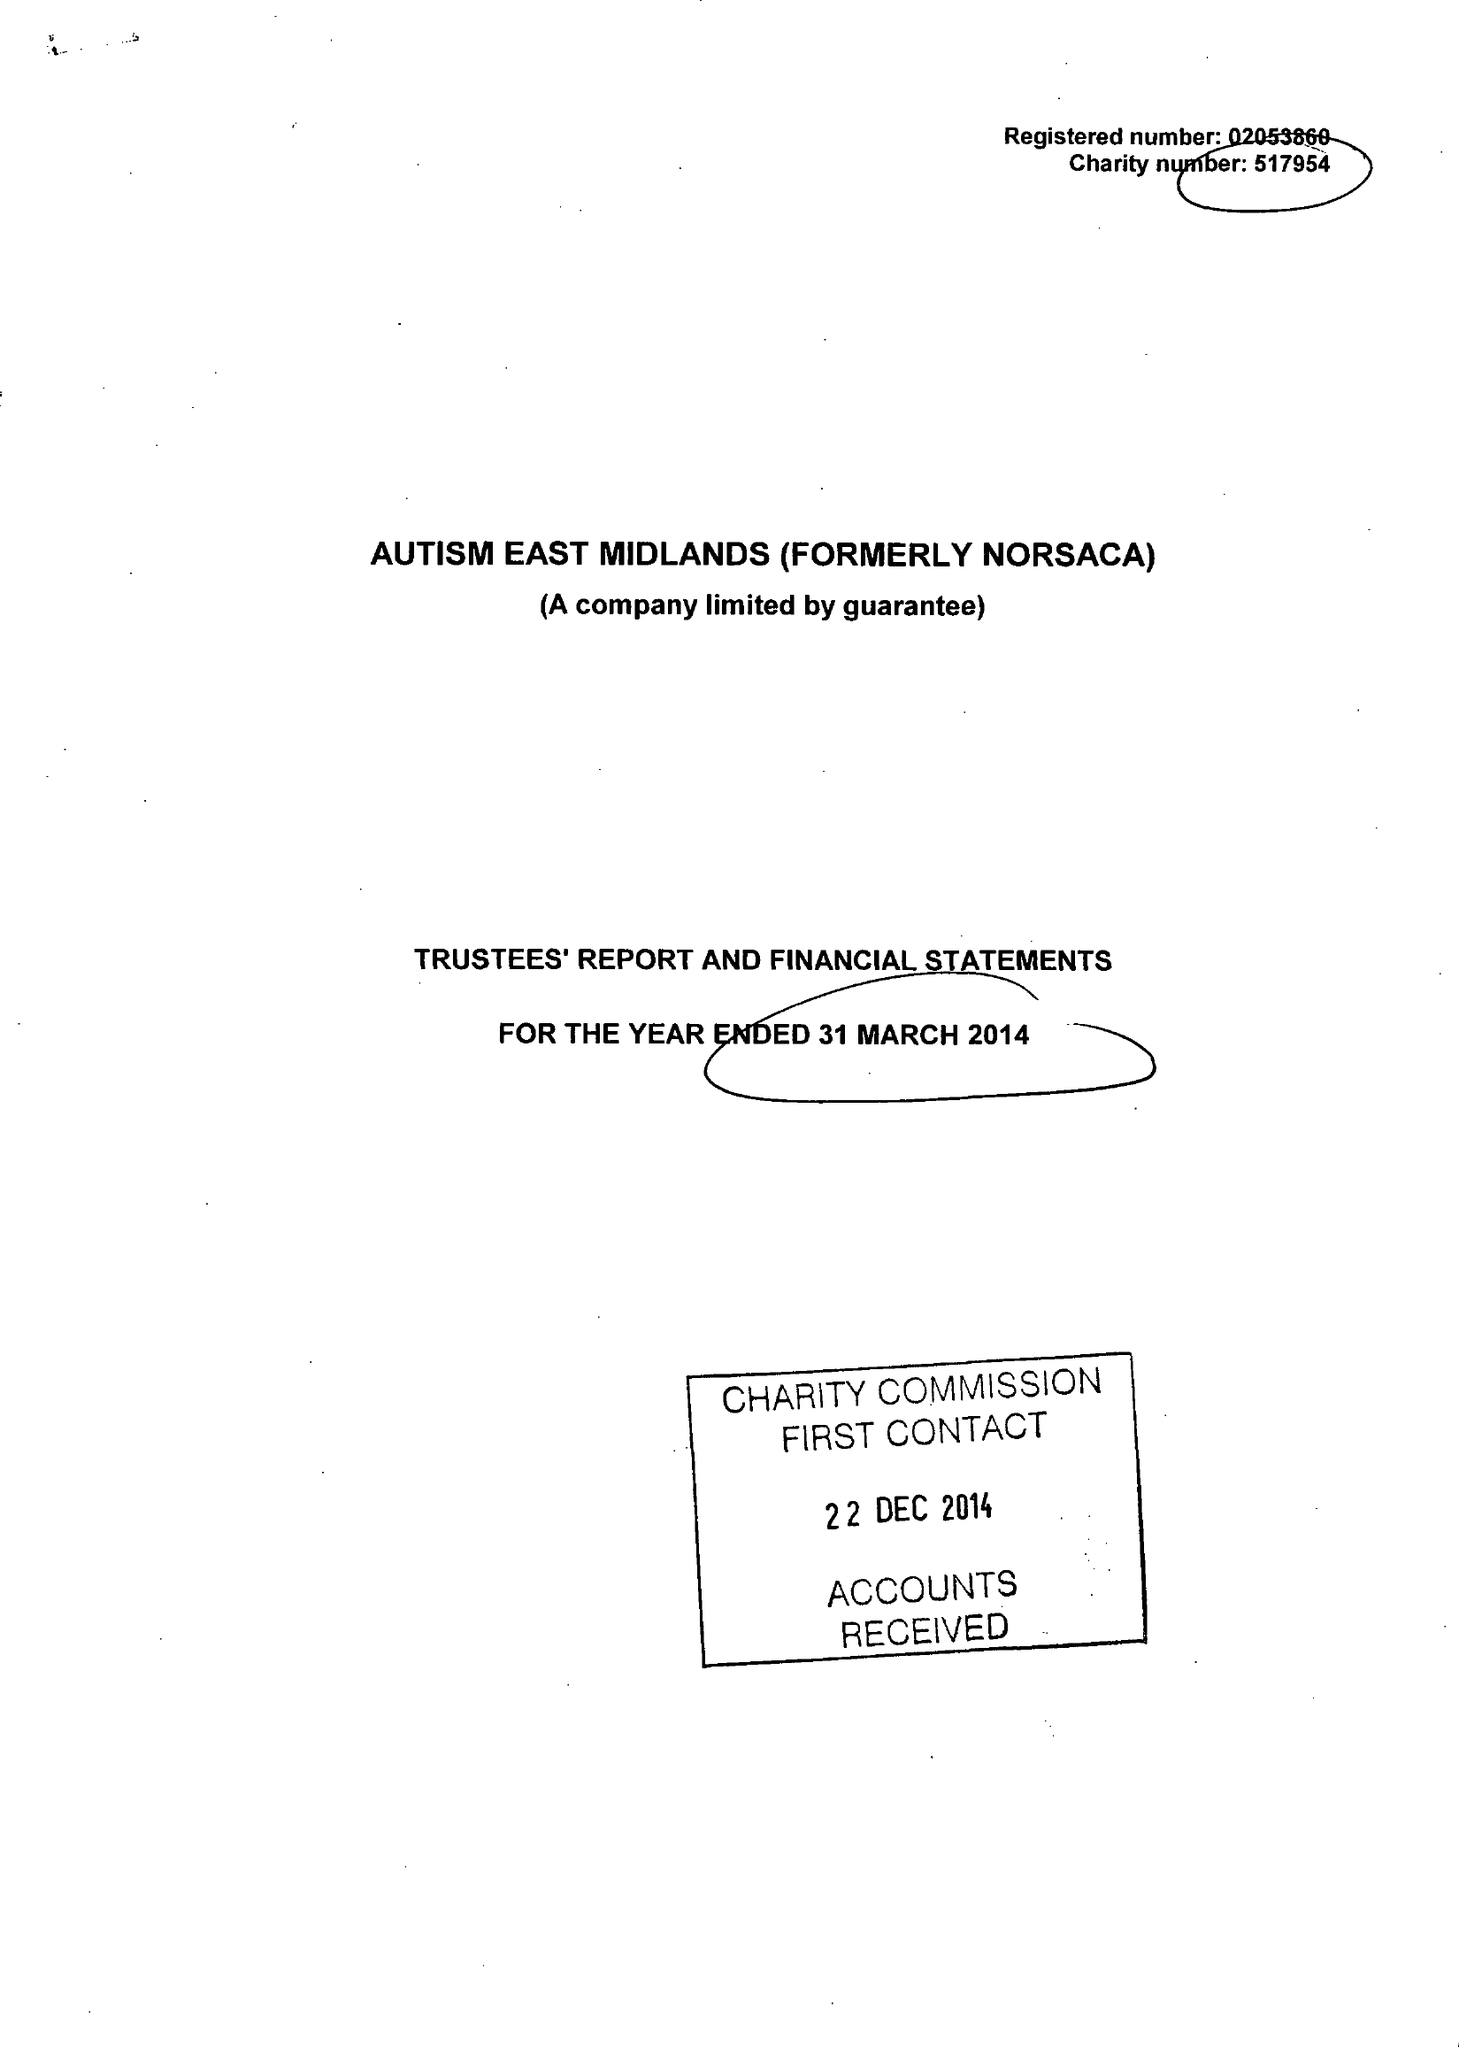What is the value for the address__postcode?
Answer the question using a single word or phrase. S80 4AJ 